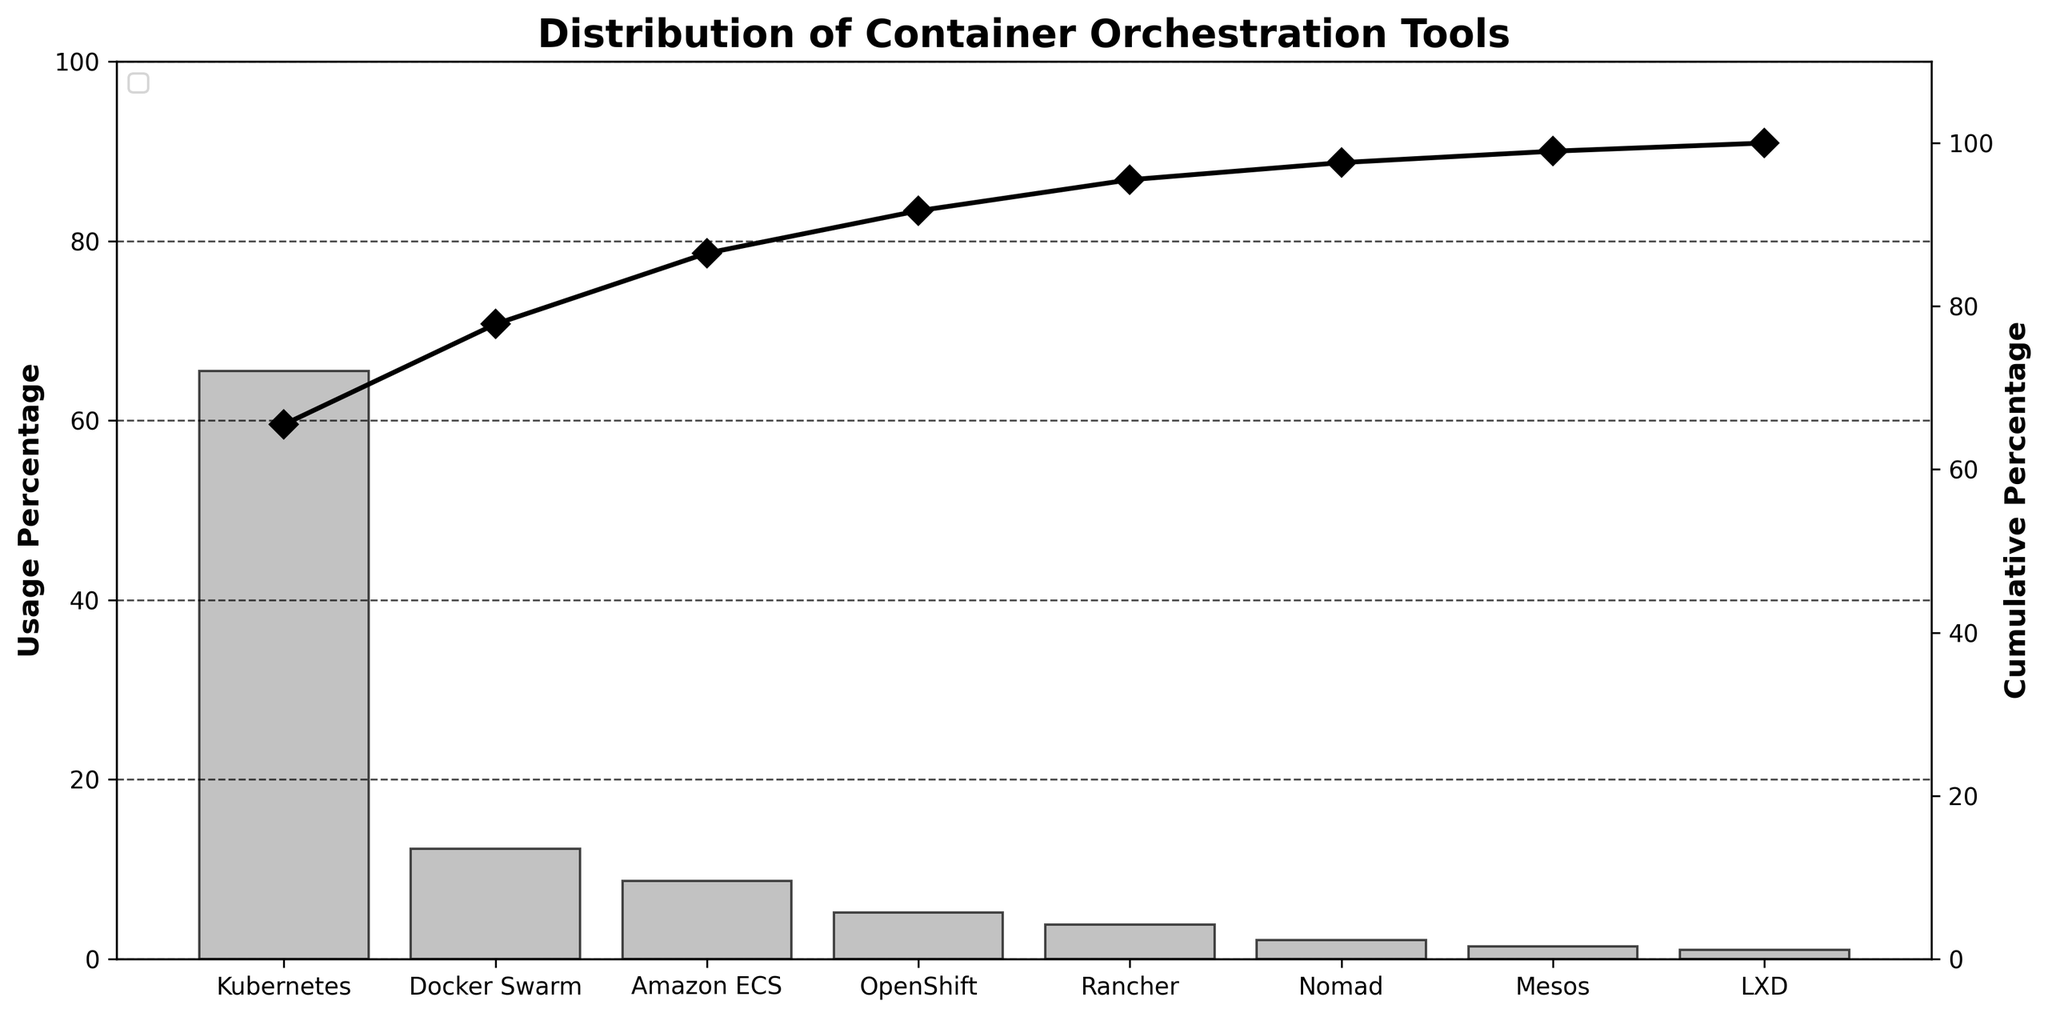What is the title of the figure? The title of the figure is displayed prominently at the top of the chart.
Answer: Distribution of Container Orchestration Tools How many different tools are shown in the figure? Count the number of distinct bars or labels on the x-axis.
Answer: 8 Which container orchestration tool has the highest usage percentage? Look for the tallest bar or the label with the highest value on the y-axis.
Answer: Kubernetes What is the usage percentage of Docker Swarm? Find the height of the bar corresponding to Docker Swarm on the y-axis.
Answer: 12.3% What is the cumulative percentage when combining Kubernetes and Docker Swarm? Sum the percentages for Kubernetes and Docker Swarm. Kubernetes has 65.5% and Docker Swarm has 12.3%. Add them together.
Answer: 77.8% Is the usage percentage of Amazon ECS greater than that of OpenShift? Compare the height of the bars for Amazon ECS and OpenShift. Amazon ECS is 8.7% and OpenShift is 5.2%.
Answer: Yes Which tool has a lower usage percentage, Rancher or Nomad? Compare the height of the bars for Rancher and Nomad. Rancher is 3.8% and Nomad is 2.1%.
Answer: Nomad What is the cumulative percentage of the top four tools? Sum the percentages for the top four tools: Kubernetes (65.5%), Docker Swarm (12.3%), Amazon ECS (8.7%), and OpenShift (5.2%). The cumulative percent is shown on the secondary y-axis at the fourth tool.
Answer: 91.7% What percentage of the cumulative usage is accounted for by the least used tool? Find the cumulative percentage on the secondary y-axis corresponding to the last tool, subtract the cumulative percentage of the tool just before it. The least used tool is LXD (1.0%). The cumulative percentage just before LXD is for Mesos (99.0%).
Answer: 1.0% By how much does the usage percentage of Kubernetes exceed the sum of Mesos and LXD? Subtract the sum of the percentages of Mesos (1.4%) and LXD (1.0%) from the percentage of Kubernetes (65.5%). 65.5 - (1.4 + 1.0) = 63.1.
Answer: 63.1% 